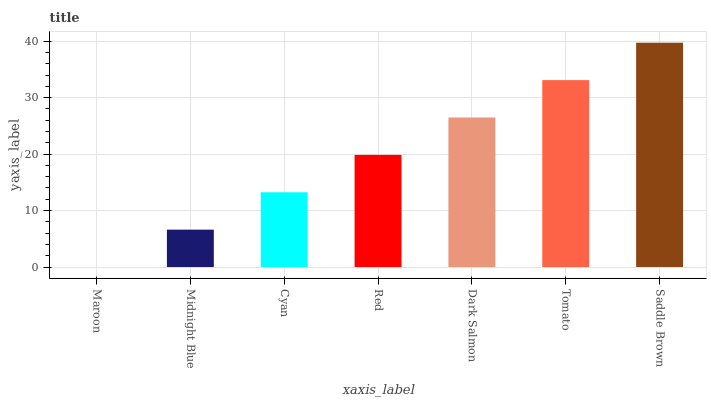Is Maroon the minimum?
Answer yes or no. Yes. Is Saddle Brown the maximum?
Answer yes or no. Yes. Is Midnight Blue the minimum?
Answer yes or no. No. Is Midnight Blue the maximum?
Answer yes or no. No. Is Midnight Blue greater than Maroon?
Answer yes or no. Yes. Is Maroon less than Midnight Blue?
Answer yes or no. Yes. Is Maroon greater than Midnight Blue?
Answer yes or no. No. Is Midnight Blue less than Maroon?
Answer yes or no. No. Is Red the high median?
Answer yes or no. Yes. Is Red the low median?
Answer yes or no. Yes. Is Maroon the high median?
Answer yes or no. No. Is Dark Salmon the low median?
Answer yes or no. No. 